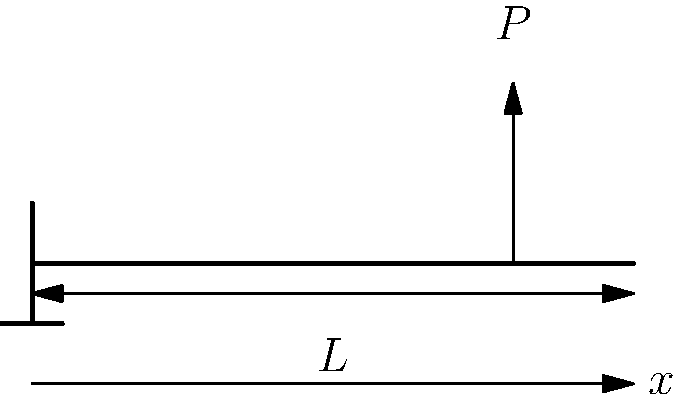A cantilever beam of length $L$ is subjected to a point load $P$ at its free end. How does the bending stress $\sigma$ vary along the length of the beam? To understand the stress distribution in a cantilever beam under a point load, let's follow these steps:

1. Recall that the bending stress $\sigma$ in a beam is given by the equation:
   
   $$\sigma = \frac{My}{I}$$

   where $M$ is the bending moment, $y$ is the distance from the neutral axis, and $I$ is the moment of inertia of the cross-section.

2. For a cantilever beam with a point load $P$ at the free end, the bending moment $M$ at any point $x$ along the beam is:
   
   $$M = P(L-x)$$

   where $L$ is the length of the beam and $x$ is the distance from the fixed end.

3. Substituting this into the stress equation:

   $$\sigma = \frac{P(L-x)y}{I}$$

4. Note that $y$ and $I$ are constants for a given cross-section.

5. The stress varies linearly with $x$, being maximum at the fixed end ($x=0$) and zero at the free end ($x=L$).

6. The maximum stress occurs at the fixed end and is given by:

   $$\sigma_{max} = \frac{PLy}{I}$$

Therefore, the bending stress decreases linearly from the fixed end to the free end of the cantilever beam.
Answer: The bending stress decreases linearly from the fixed end to the free end. 